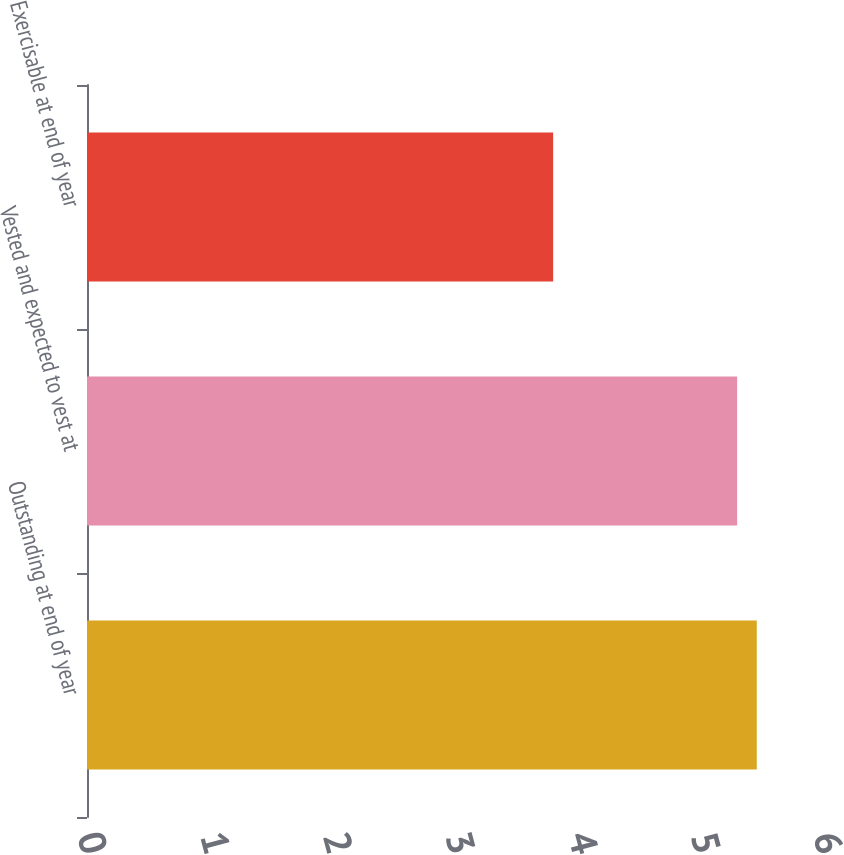Convert chart. <chart><loc_0><loc_0><loc_500><loc_500><bar_chart><fcel>Outstanding at end of year<fcel>Vested and expected to vest at<fcel>Exercisable at end of year<nl><fcel>5.46<fcel>5.3<fcel>3.8<nl></chart> 